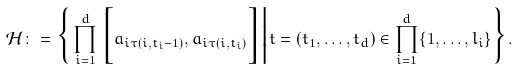<formula> <loc_0><loc_0><loc_500><loc_500>\mathcal { H } \colon = \Big \{ \prod _ { i = 1 } ^ { d } \Big [ a _ { i \tau ( i , t _ { i } - 1 ) } , a _ { i \tau ( i , t _ { i } ) } \Big ] \Big | t = ( t _ { 1 } , \dots , t _ { d } ) \in \prod _ { i = 1 } ^ { d } \{ 1 , \dots , l _ { i } \} \Big \} .</formula> 